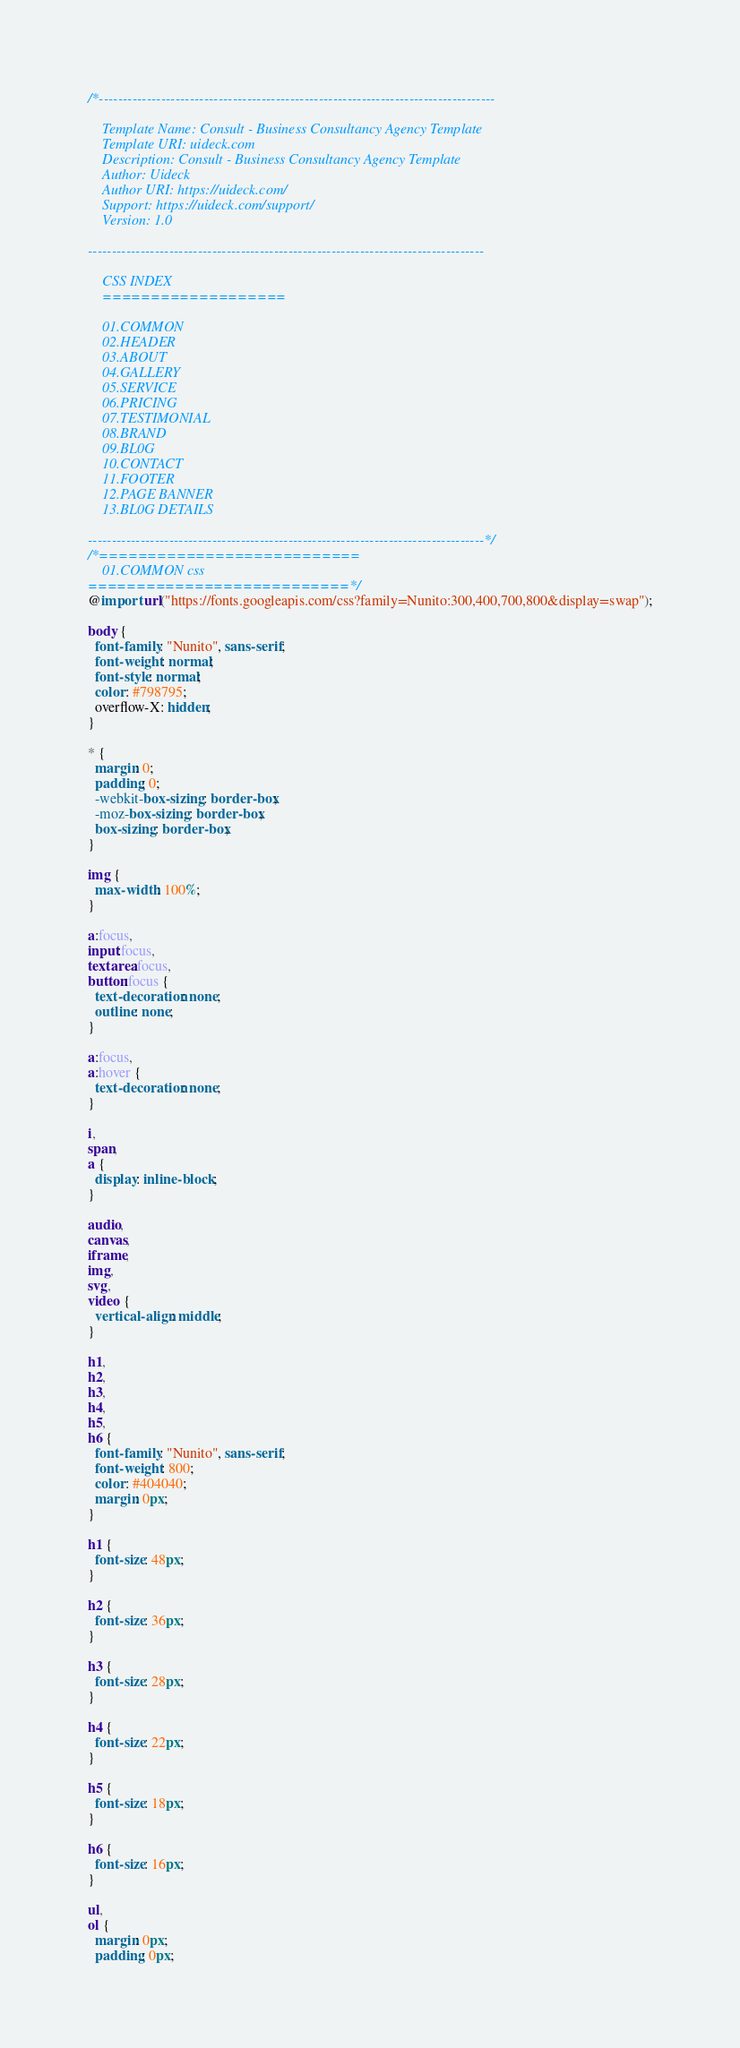Convert code to text. <code><loc_0><loc_0><loc_500><loc_500><_CSS_>/*-----------------------------------------------------------------------------------

    Template Name: Consult - Business Consultancy Agency Template
    Template URI: uideck.com
    Description: Consult - Business Consultancy Agency Template
    Author: Uideck
    Author URI: https://uideck.com/
    Support: https://uideck.com/support/
    Version: 1.0

-----------------------------------------------------------------------------------

    CSS INDEX
    ===================

    01.COMMON
    02.HEADER
    03.ABOUT
    04.GALLERY
    05.SERVICE
    06.PRICING
    07.TESTIMONIAL
    08.BRAND
    09.BL0G
    10.CONTACT
    11.FOOTER
    12.PAGE BANNER
    13.BL0G DETAILS

-----------------------------------------------------------------------------------*/
/*===========================
    01.COMMON css 
===========================*/
@import url("https://fonts.googleapis.com/css?family=Nunito:300,400,700,800&display=swap");

body {
  font-family: "Nunito", sans-serif;
  font-weight: normal;
  font-style: normal;
  color: #798795;
  overflow-X: hidden;
}

* {
  margin: 0;
  padding: 0;
  -webkit-box-sizing: border-box;
  -moz-box-sizing: border-box;
  box-sizing: border-box;
}

img {
  max-width: 100%;
}

a:focus,
input:focus,
textarea:focus,
button:focus {
  text-decoration: none;
  outline: none;
}

a:focus,
a:hover {
  text-decoration: none;
}

i,
span,
a {
  display: inline-block;
}

audio,
canvas,
iframe,
img,
svg,
video {
  vertical-align: middle;
}

h1,
h2,
h3,
h4,
h5,
h6 {
  font-family: "Nunito", sans-serif;
  font-weight: 800;
  color: #404040;
  margin: 0px;
}

h1 {
  font-size: 48px;
}

h2 {
  font-size: 36px;
}

h3 {
  font-size: 28px;
}

h4 {
  font-size: 22px;
}

h5 {
  font-size: 18px;
}

h6 {
  font-size: 16px;
}

ul,
ol {
  margin: 0px;
  padding: 0px;</code> 